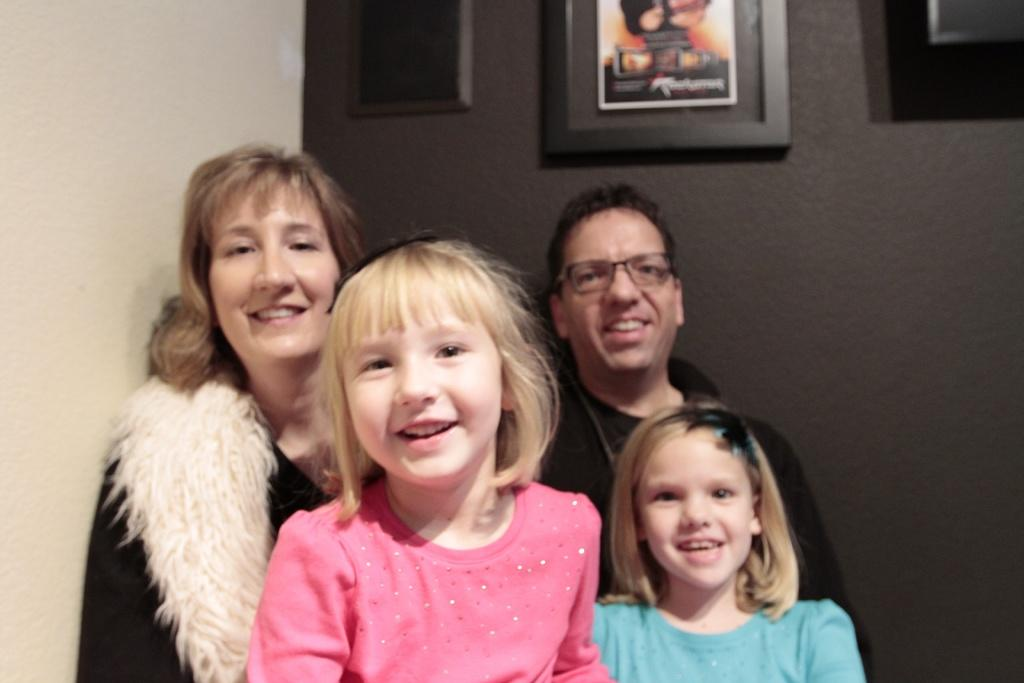Who is present in the image? There is a family in the image, consisting of two kids and a couple. What can be seen in the background of the image? There is a wall in the background of the image. What is on the wall in the image? There are three frames on the wall. What type of linen is draped over the building in the image? There is no building or linen present in the image; it features a family and a wall with frames. What toys are the kids playing with in the image? There is no indication in the image that the kids are playing with any toys. 